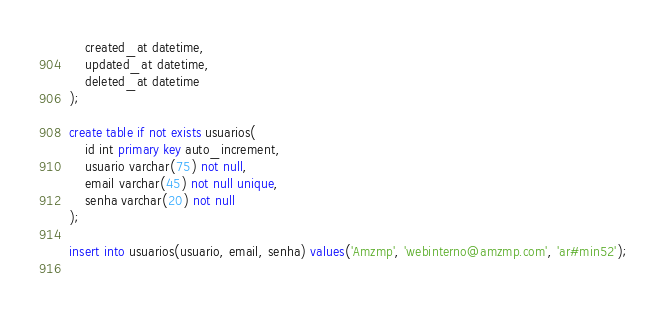<code> <loc_0><loc_0><loc_500><loc_500><_SQL_>	created_at datetime,
	updated_at datetime,
	deleted_at datetime
);

create table if not exists usuarios(
	id int primary key auto_increment,
	usuario varchar(75) not null,
	email varchar(45) not null unique,
	senha varchar(20) not null
);

insert into usuarios(usuario, email, senha) values('Amzmp', 'webinterno@amzmp.com', 'ar#min52');
		
</code> 